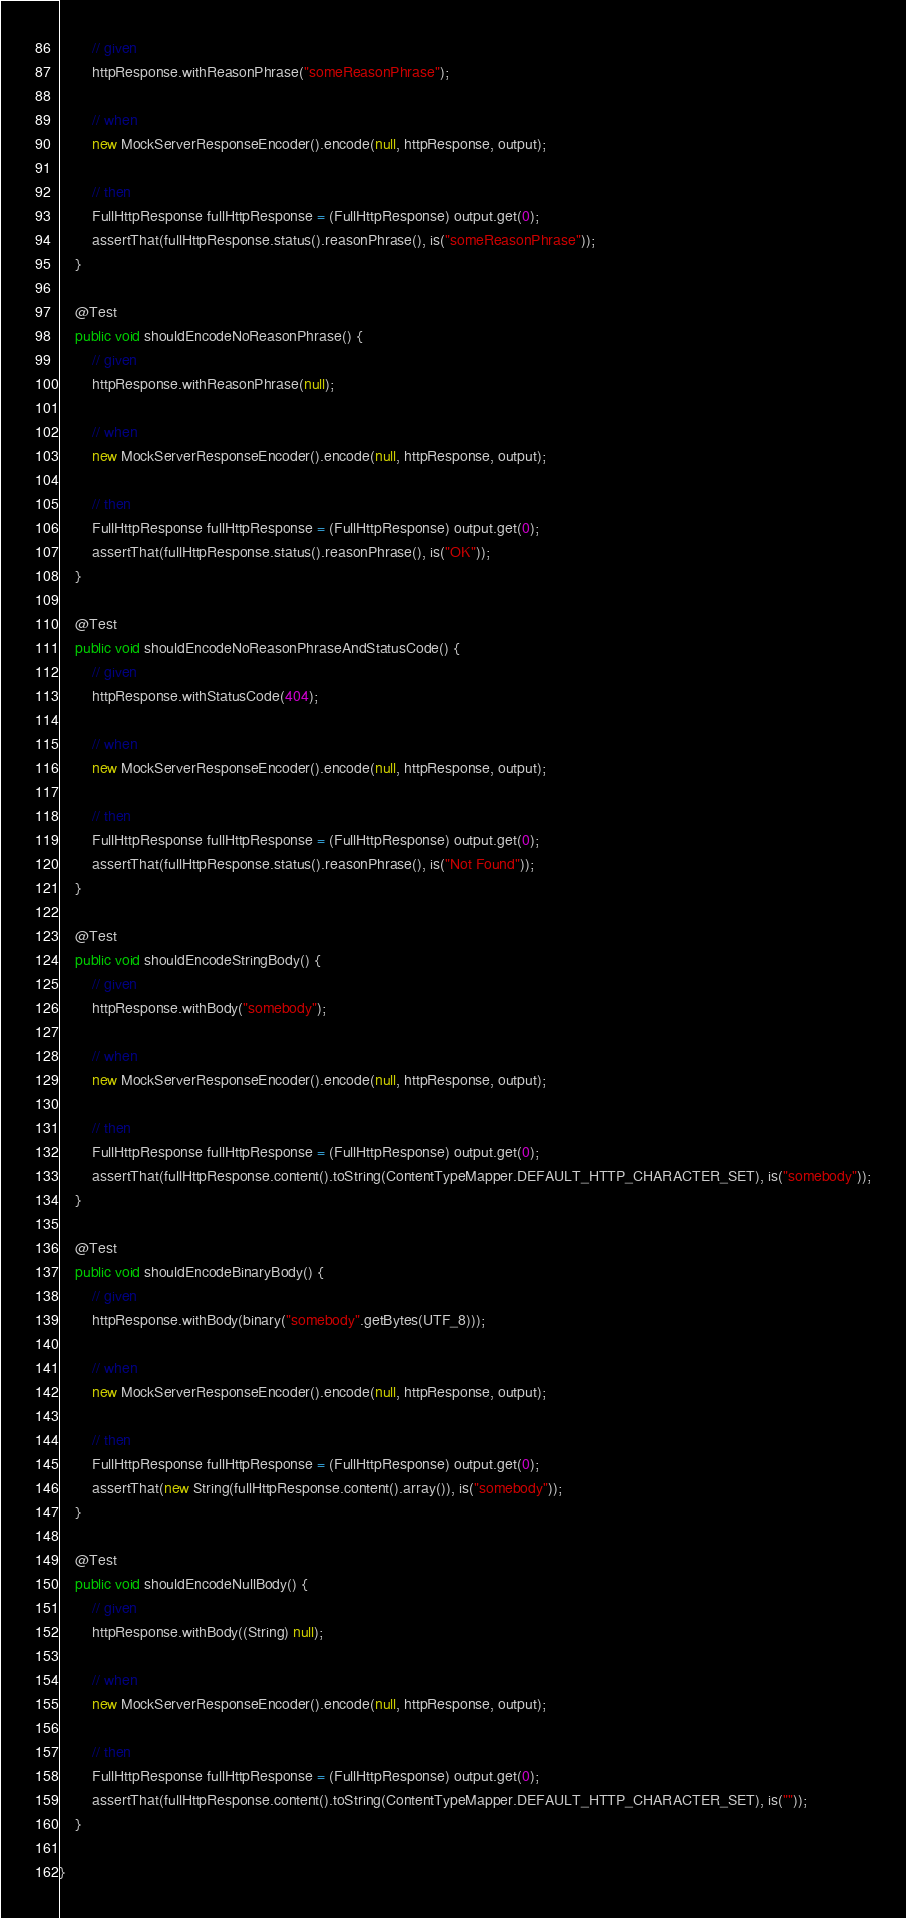<code> <loc_0><loc_0><loc_500><loc_500><_Java_>        // given
        httpResponse.withReasonPhrase("someReasonPhrase");

        // when
        new MockServerResponseEncoder().encode(null, httpResponse, output);

        // then
        FullHttpResponse fullHttpResponse = (FullHttpResponse) output.get(0);
        assertThat(fullHttpResponse.status().reasonPhrase(), is("someReasonPhrase"));
    }

    @Test
    public void shouldEncodeNoReasonPhrase() {
        // given
        httpResponse.withReasonPhrase(null);

        // when
        new MockServerResponseEncoder().encode(null, httpResponse, output);

        // then
        FullHttpResponse fullHttpResponse = (FullHttpResponse) output.get(0);
        assertThat(fullHttpResponse.status().reasonPhrase(), is("OK"));
    }

    @Test
    public void shouldEncodeNoReasonPhraseAndStatusCode() {
        // given
        httpResponse.withStatusCode(404);

        // when
        new MockServerResponseEncoder().encode(null, httpResponse, output);

        // then
        FullHttpResponse fullHttpResponse = (FullHttpResponse) output.get(0);
        assertThat(fullHttpResponse.status().reasonPhrase(), is("Not Found"));
    }

    @Test
    public void shouldEncodeStringBody() {
        // given
        httpResponse.withBody("somebody");

        // when
        new MockServerResponseEncoder().encode(null, httpResponse, output);

        // then
        FullHttpResponse fullHttpResponse = (FullHttpResponse) output.get(0);
        assertThat(fullHttpResponse.content().toString(ContentTypeMapper.DEFAULT_HTTP_CHARACTER_SET), is("somebody"));
    }

    @Test
    public void shouldEncodeBinaryBody() {
        // given
        httpResponse.withBody(binary("somebody".getBytes(UTF_8)));

        // when
        new MockServerResponseEncoder().encode(null, httpResponse, output);

        // then
        FullHttpResponse fullHttpResponse = (FullHttpResponse) output.get(0);
        assertThat(new String(fullHttpResponse.content().array()), is("somebody"));
    }

    @Test
    public void shouldEncodeNullBody() {
        // given
        httpResponse.withBody((String) null);

        // when
        new MockServerResponseEncoder().encode(null, httpResponse, output);

        // then
        FullHttpResponse fullHttpResponse = (FullHttpResponse) output.get(0);
        assertThat(fullHttpResponse.content().toString(ContentTypeMapper.DEFAULT_HTTP_CHARACTER_SET), is(""));
    }

}
</code> 